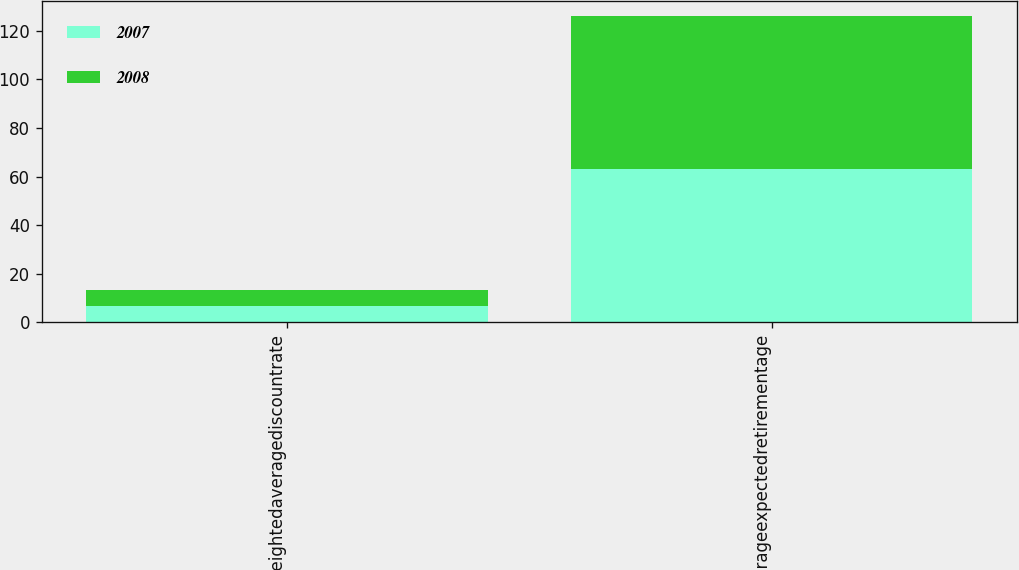Convert chart. <chart><loc_0><loc_0><loc_500><loc_500><stacked_bar_chart><ecel><fcel>Weightedaveragediscountrate<fcel>Averageexpectedretirementage<nl><fcel>2007<fcel>6.6<fcel>63<nl><fcel>2008<fcel>6.65<fcel>63<nl></chart> 